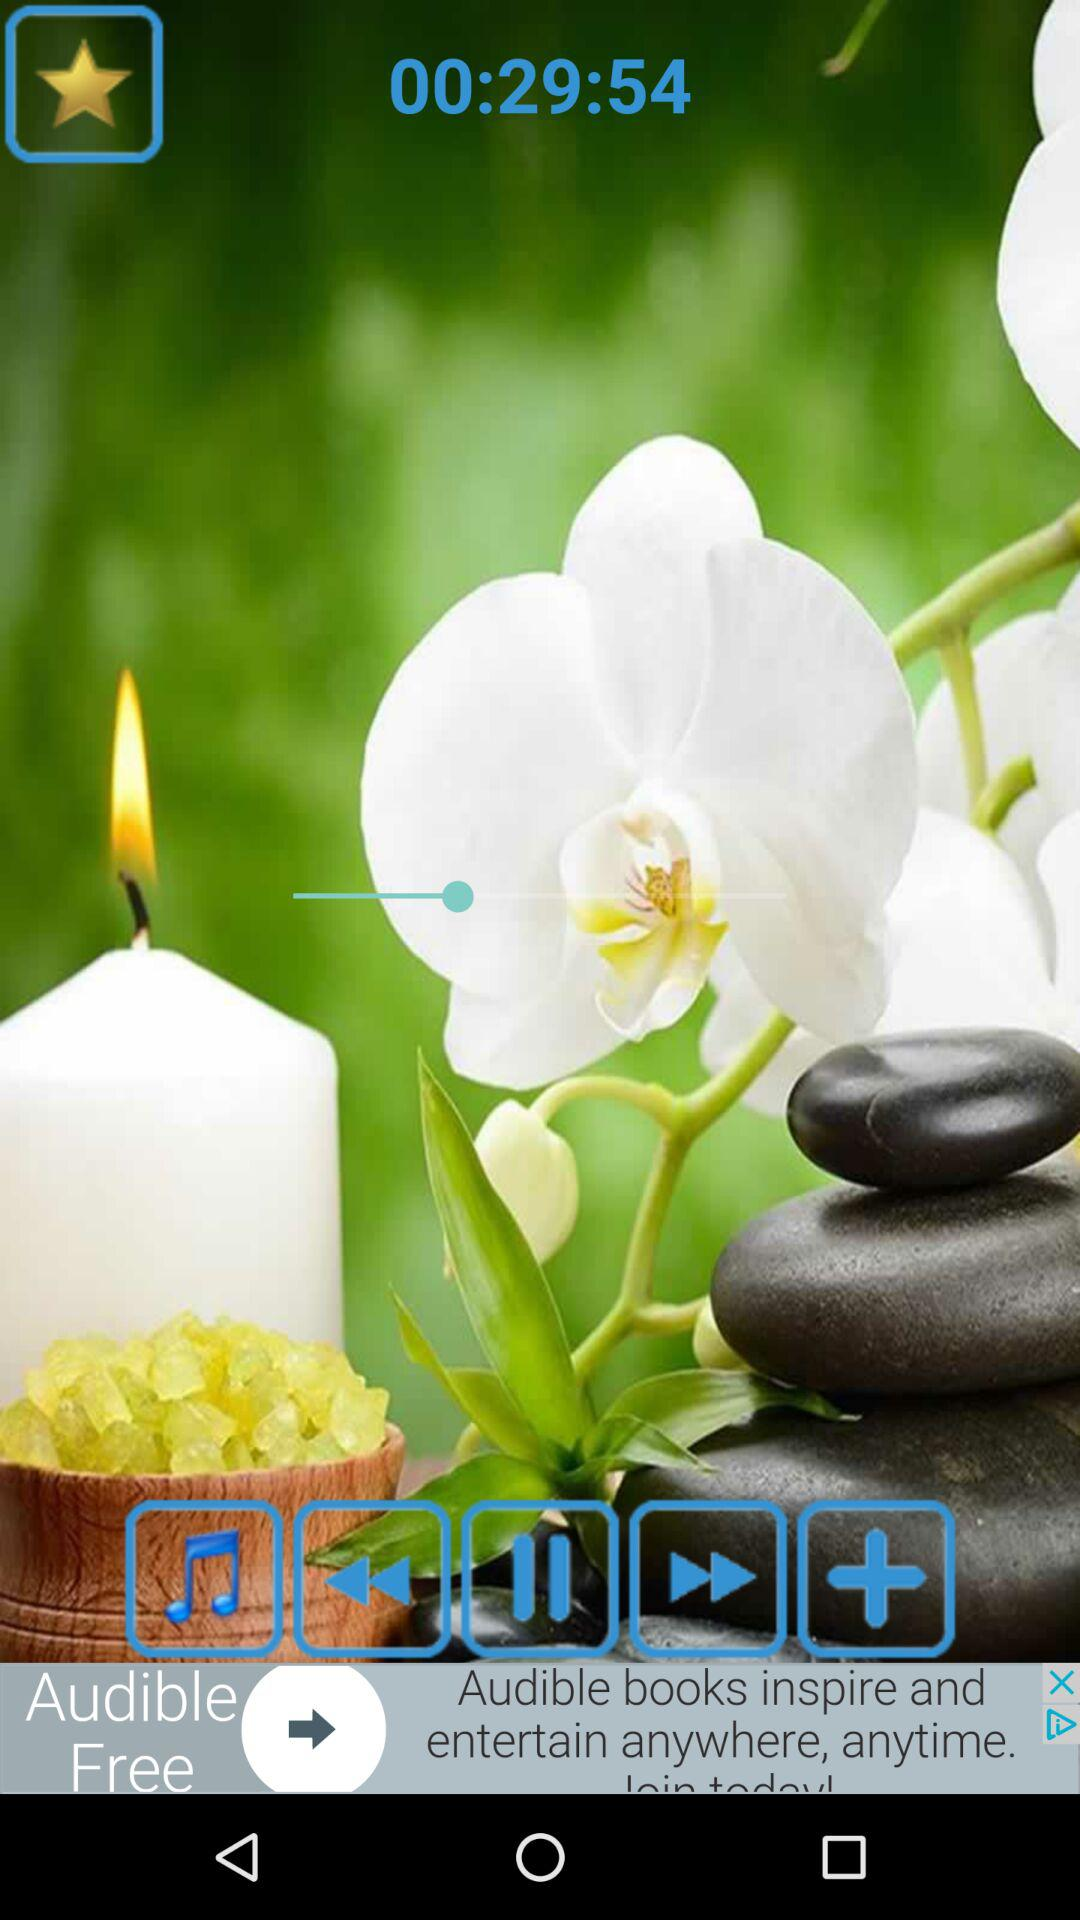What is the time left for the video? The time left for the video is 29 minutes and 54 seconds. 